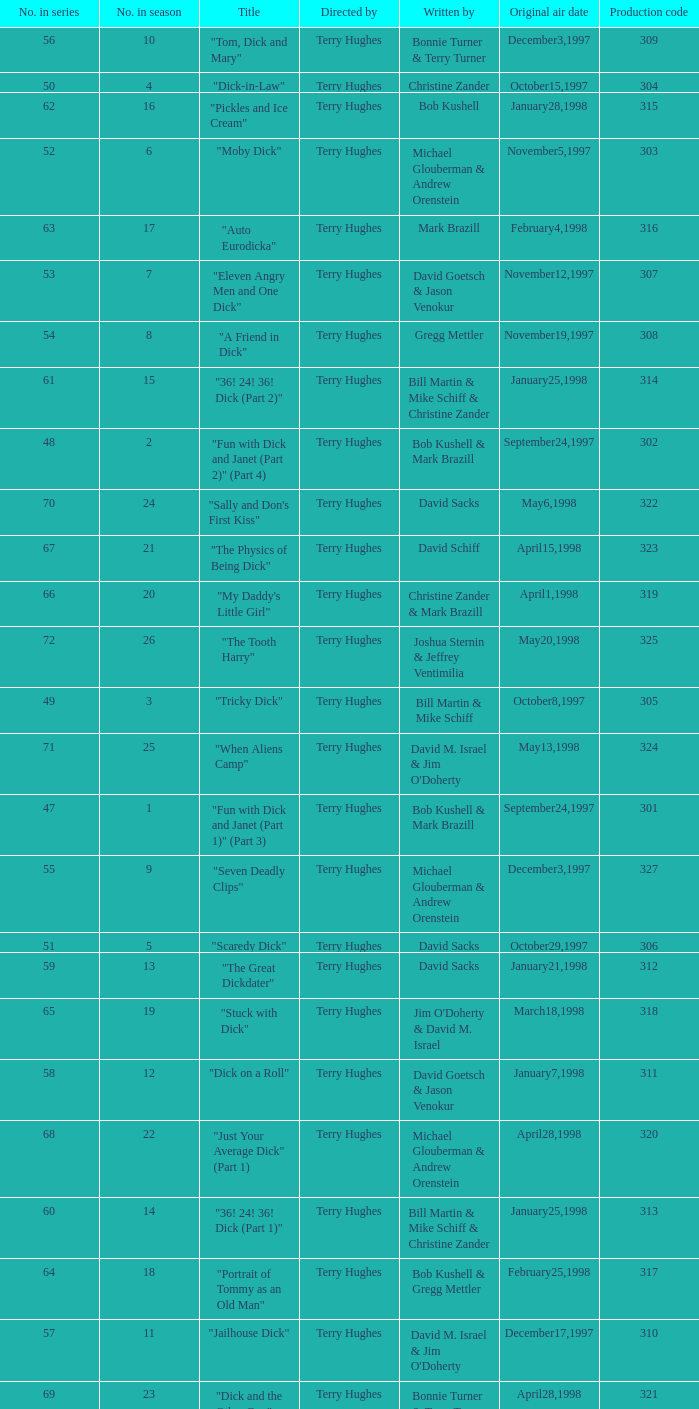What is the original air date of the episode with production code is 319? April1,1998. 